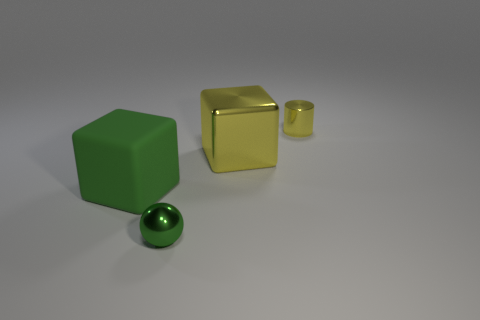Add 1 large brown rubber things. How many objects exist? 5 Subtract 0 cyan blocks. How many objects are left? 4 Subtract all spheres. How many objects are left? 3 Subtract 1 cylinders. How many cylinders are left? 0 Subtract all purple cubes. Subtract all yellow cylinders. How many cubes are left? 2 Subtract all brown cylinders. How many green blocks are left? 1 Subtract all yellow cubes. Subtract all cyan cylinders. How many objects are left? 3 Add 1 small cylinders. How many small cylinders are left? 2 Add 4 large rubber things. How many large rubber things exist? 5 